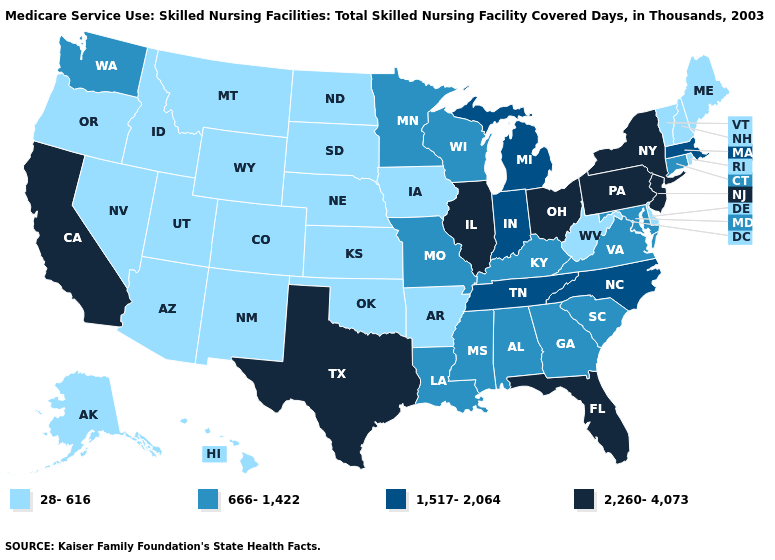What is the lowest value in the South?
Be succinct. 28-616. What is the lowest value in the South?
Concise answer only. 28-616. Name the states that have a value in the range 666-1,422?
Be succinct. Alabama, Connecticut, Georgia, Kentucky, Louisiana, Maryland, Minnesota, Mississippi, Missouri, South Carolina, Virginia, Washington, Wisconsin. What is the value of Maryland?
Keep it brief. 666-1,422. What is the highest value in the USA?
Quick response, please. 2,260-4,073. Name the states that have a value in the range 666-1,422?
Keep it brief. Alabama, Connecticut, Georgia, Kentucky, Louisiana, Maryland, Minnesota, Mississippi, Missouri, South Carolina, Virginia, Washington, Wisconsin. Name the states that have a value in the range 2,260-4,073?
Quick response, please. California, Florida, Illinois, New Jersey, New York, Ohio, Pennsylvania, Texas. Name the states that have a value in the range 666-1,422?
Be succinct. Alabama, Connecticut, Georgia, Kentucky, Louisiana, Maryland, Minnesota, Mississippi, Missouri, South Carolina, Virginia, Washington, Wisconsin. Name the states that have a value in the range 1,517-2,064?
Answer briefly. Indiana, Massachusetts, Michigan, North Carolina, Tennessee. Does Montana have the lowest value in the USA?
Short answer required. Yes. Does Vermont have the lowest value in the Northeast?
Short answer required. Yes. Name the states that have a value in the range 28-616?
Be succinct. Alaska, Arizona, Arkansas, Colorado, Delaware, Hawaii, Idaho, Iowa, Kansas, Maine, Montana, Nebraska, Nevada, New Hampshire, New Mexico, North Dakota, Oklahoma, Oregon, Rhode Island, South Dakota, Utah, Vermont, West Virginia, Wyoming. Among the states that border Louisiana , does Texas have the highest value?
Keep it brief. Yes. What is the lowest value in the MidWest?
Answer briefly. 28-616. Does South Dakota have the lowest value in the MidWest?
Keep it brief. Yes. 